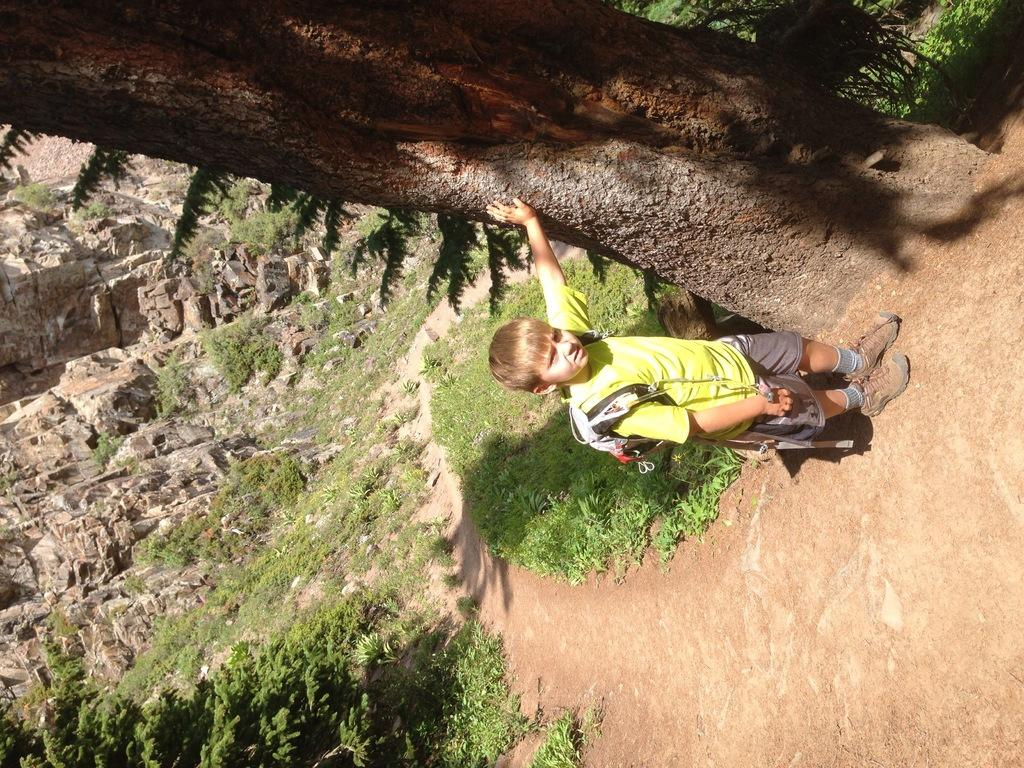Who is the main subject in the image? There is a boy in the image. What is the boy wearing? The boy is wearing a bag. What is the boy's posture in the image? The boy is standing. What type of vegetation can be seen in the image? There is a tree, grass, and plants in the image. What other natural elements are present in the image? There are rocks in the image. Can you tell me how many houses are visible in the image? There are no houses visible in the image. Who is the expert in the image? There is no expert present in the image; it features a boy standing with various natural elements. 